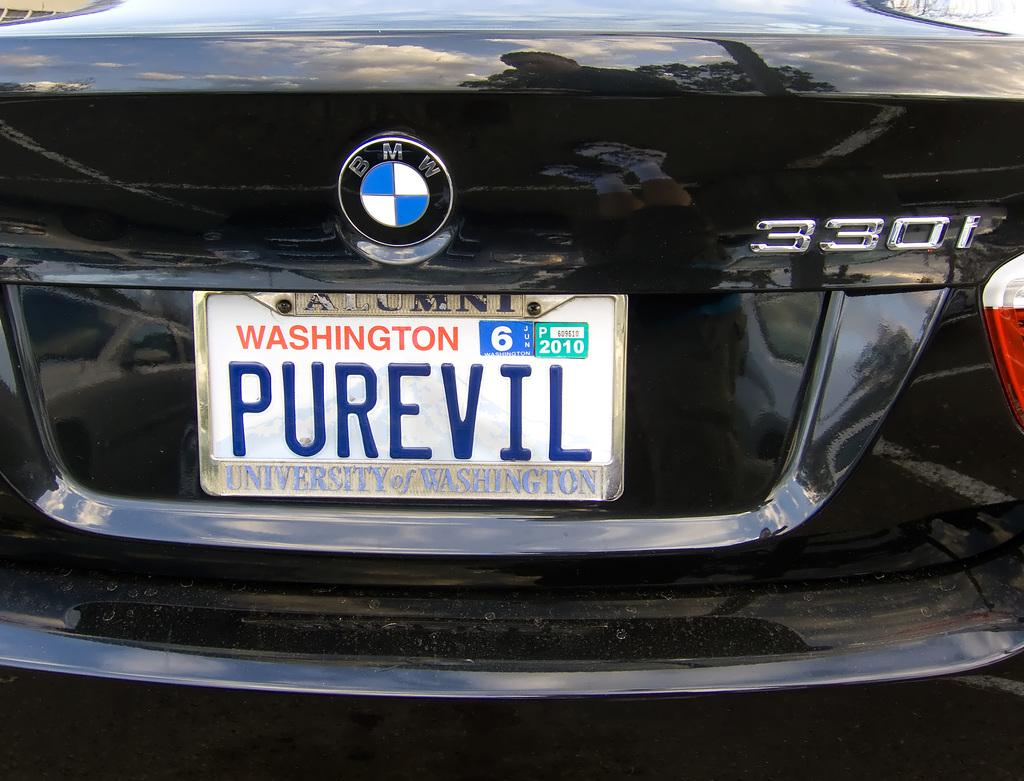<image>
Describe the image concisely. A black BMW with a Washington tag that says PUREVIL. 